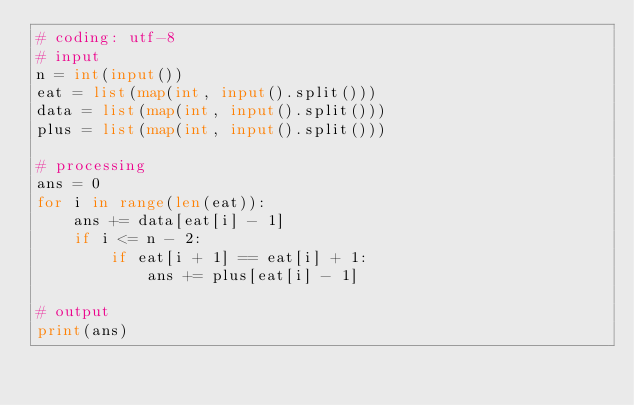<code> <loc_0><loc_0><loc_500><loc_500><_Python_># coding: utf-8
# input
n = int(input())
eat = list(map(int, input().split()))
data = list(map(int, input().split()))
plus = list(map(int, input().split()))

# processing
ans = 0
for i in range(len(eat)):
    ans += data[eat[i] - 1]
    if i <= n - 2:
        if eat[i + 1] == eat[i] + 1:
            ans += plus[eat[i] - 1]

# output
print(ans)
</code> 